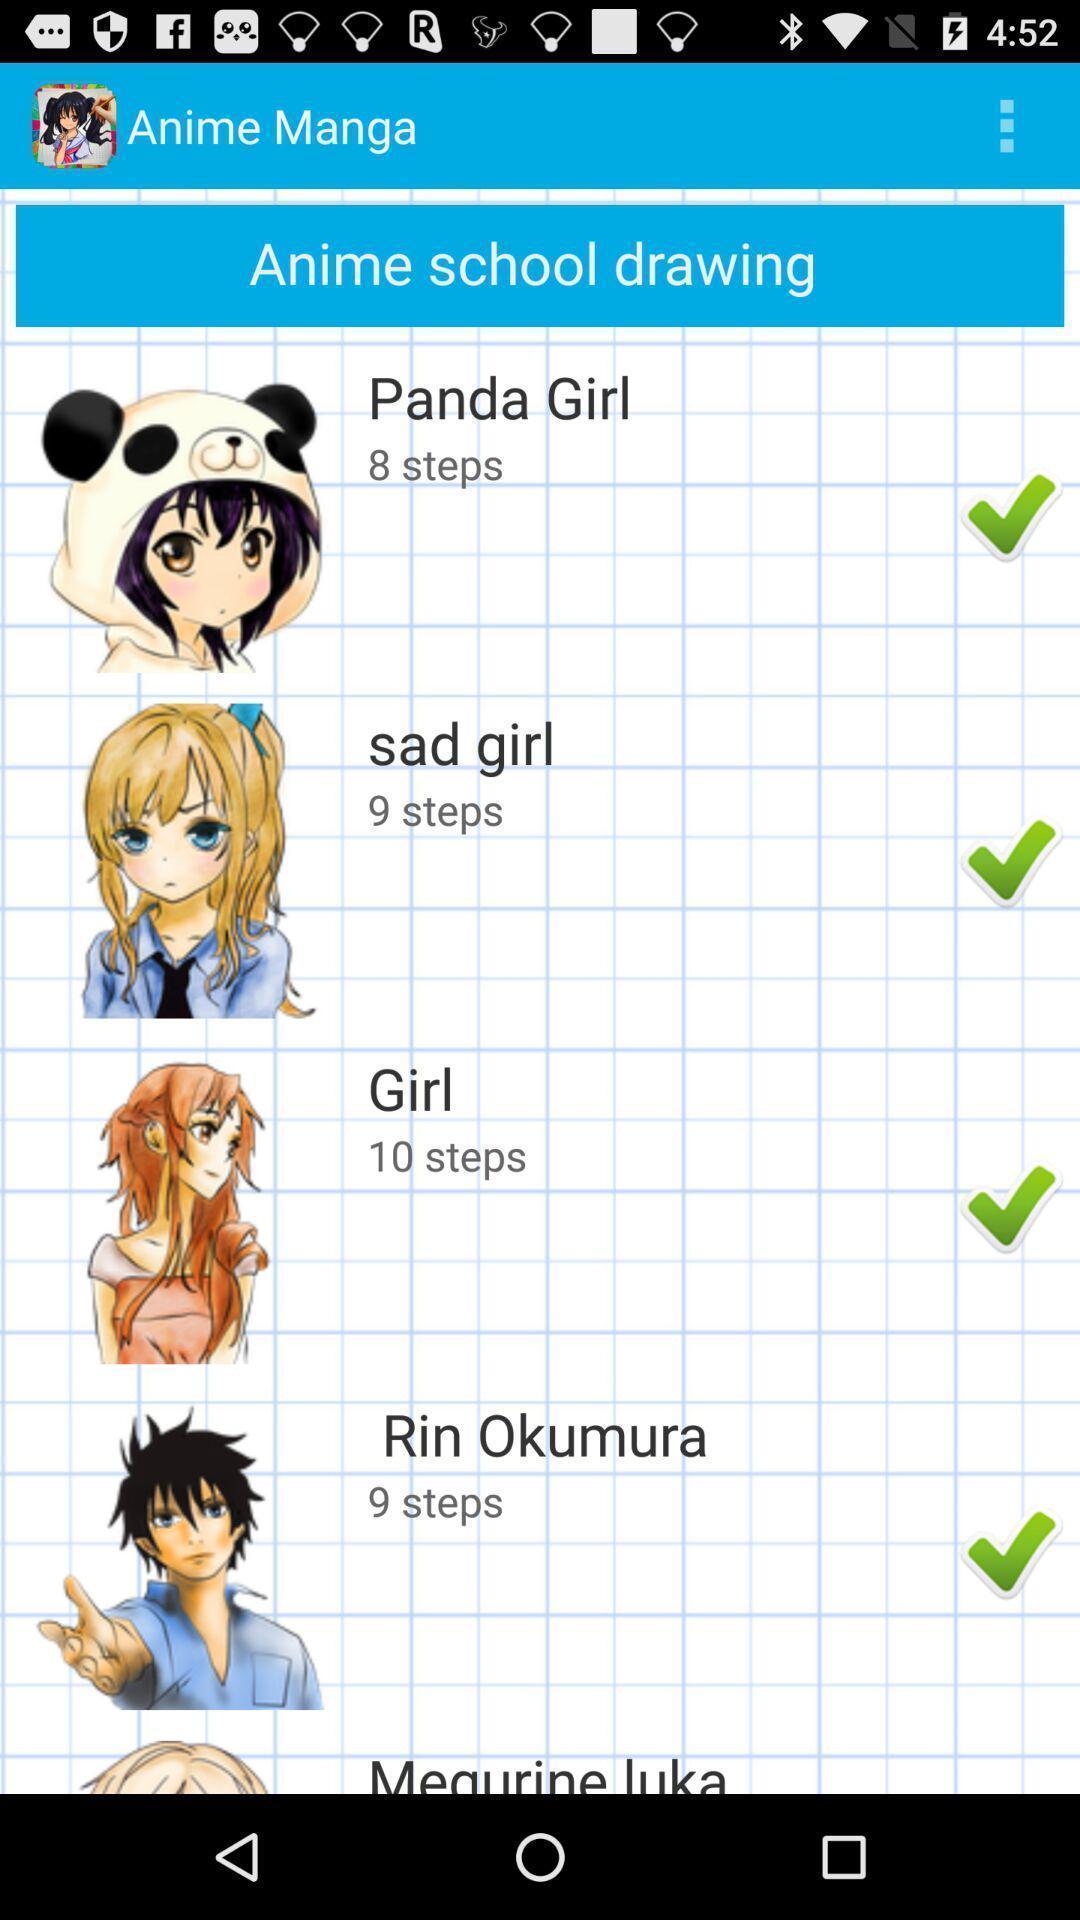Tell me what you see in this picture. Screen shows different levels of school drawing. 